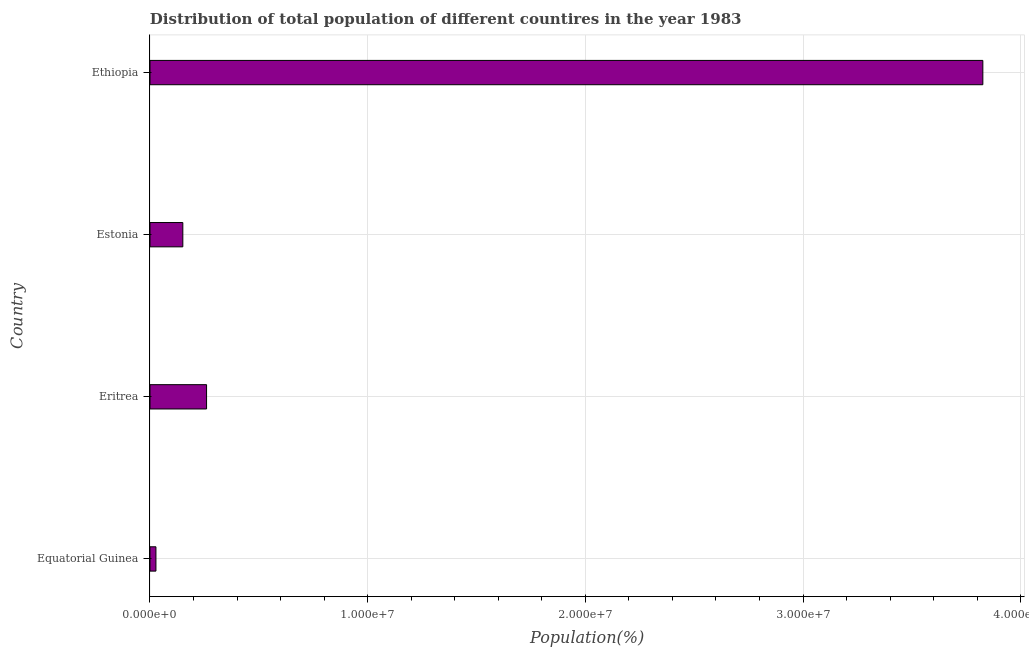What is the title of the graph?
Your answer should be very brief. Distribution of total population of different countires in the year 1983. What is the label or title of the X-axis?
Your answer should be compact. Population(%). What is the population in Eritrea?
Offer a very short reply. 2.60e+06. Across all countries, what is the maximum population?
Your answer should be very brief. 3.83e+07. Across all countries, what is the minimum population?
Provide a succinct answer. 2.73e+05. In which country was the population maximum?
Your response must be concise. Ethiopia. In which country was the population minimum?
Make the answer very short. Equatorial Guinea. What is the sum of the population?
Your answer should be very brief. 4.26e+07. What is the difference between the population in Equatorial Guinea and Estonia?
Provide a short and direct response. -1.24e+06. What is the average population per country?
Your response must be concise. 1.07e+07. What is the median population?
Provide a succinct answer. 2.05e+06. In how many countries, is the population greater than 30000000 %?
Make the answer very short. 1. What is the ratio of the population in Eritrea to that in Ethiopia?
Give a very brief answer. 0.07. What is the difference between the highest and the second highest population?
Your response must be concise. 3.57e+07. Is the sum of the population in Eritrea and Ethiopia greater than the maximum population across all countries?
Your response must be concise. Yes. What is the difference between the highest and the lowest population?
Ensure brevity in your answer.  3.80e+07. In how many countries, is the population greater than the average population taken over all countries?
Provide a succinct answer. 1. How many bars are there?
Ensure brevity in your answer.  4. Are all the bars in the graph horizontal?
Provide a succinct answer. Yes. How many countries are there in the graph?
Offer a terse response. 4. What is the difference between two consecutive major ticks on the X-axis?
Give a very brief answer. 1.00e+07. What is the Population(%) of Equatorial Guinea?
Provide a short and direct response. 2.73e+05. What is the Population(%) of Eritrea?
Keep it short and to the point. 2.60e+06. What is the Population(%) in Estonia?
Keep it short and to the point. 1.51e+06. What is the Population(%) of Ethiopia?
Keep it short and to the point. 3.83e+07. What is the difference between the Population(%) in Equatorial Guinea and Eritrea?
Offer a terse response. -2.33e+06. What is the difference between the Population(%) in Equatorial Guinea and Estonia?
Offer a terse response. -1.24e+06. What is the difference between the Population(%) in Equatorial Guinea and Ethiopia?
Your answer should be compact. -3.80e+07. What is the difference between the Population(%) in Eritrea and Estonia?
Offer a very short reply. 1.09e+06. What is the difference between the Population(%) in Eritrea and Ethiopia?
Keep it short and to the point. -3.57e+07. What is the difference between the Population(%) in Estonia and Ethiopia?
Provide a succinct answer. -3.68e+07. What is the ratio of the Population(%) in Equatorial Guinea to that in Eritrea?
Your answer should be very brief. 0.1. What is the ratio of the Population(%) in Equatorial Guinea to that in Estonia?
Provide a succinct answer. 0.18. What is the ratio of the Population(%) in Equatorial Guinea to that in Ethiopia?
Your answer should be compact. 0.01. What is the ratio of the Population(%) in Eritrea to that in Estonia?
Provide a short and direct response. 1.72. What is the ratio of the Population(%) in Eritrea to that in Ethiopia?
Your answer should be compact. 0.07. What is the ratio of the Population(%) in Estonia to that in Ethiopia?
Your answer should be compact. 0.04. 